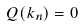Convert formula to latex. <formula><loc_0><loc_0><loc_500><loc_500>Q ( k _ { n } ) = 0</formula> 